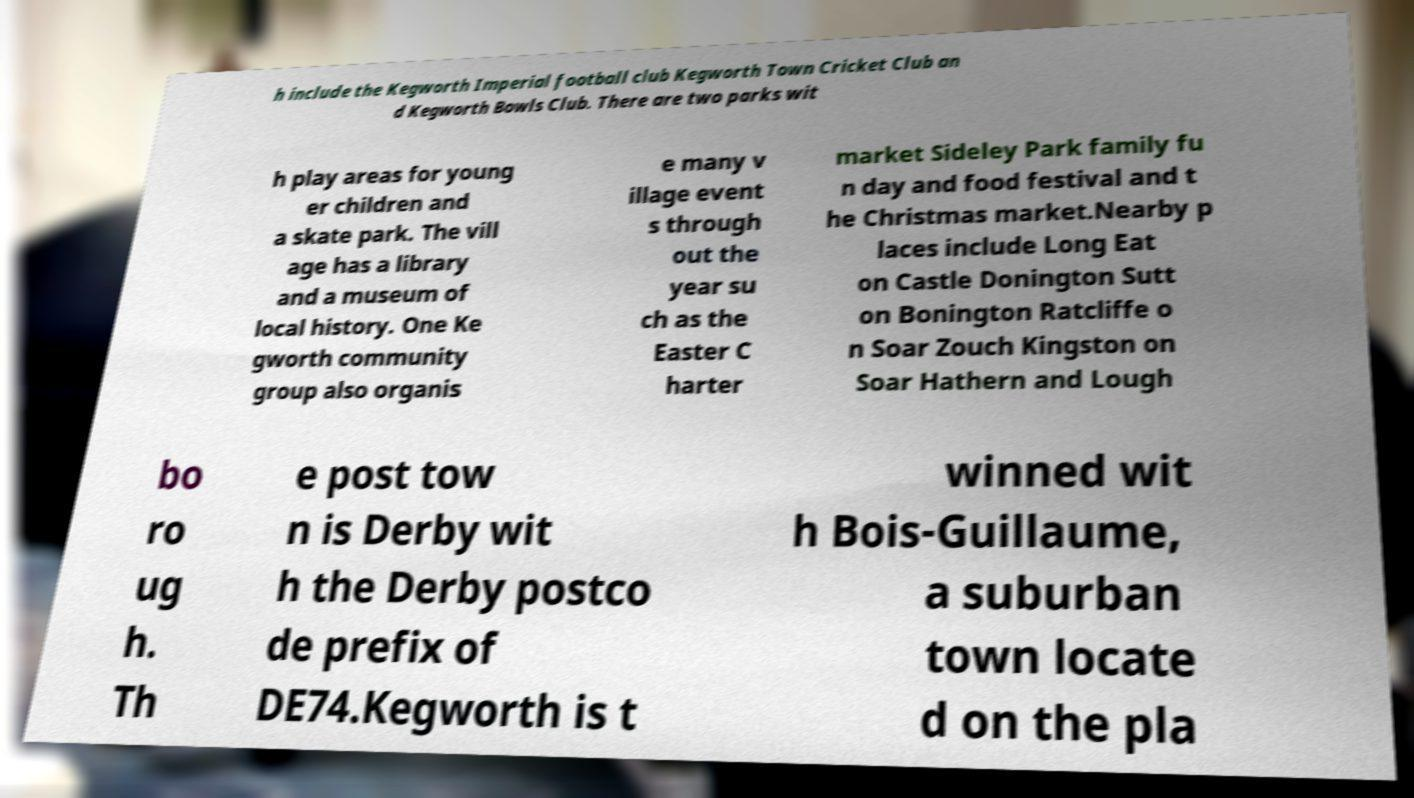Can you read and provide the text displayed in the image?This photo seems to have some interesting text. Can you extract and type it out for me? h include the Kegworth Imperial football club Kegworth Town Cricket Club an d Kegworth Bowls Club. There are two parks wit h play areas for young er children and a skate park. The vill age has a library and a museum of local history. One Ke gworth community group also organis e many v illage event s through out the year su ch as the Easter C harter market Sideley Park family fu n day and food festival and t he Christmas market.Nearby p laces include Long Eat on Castle Donington Sutt on Bonington Ratcliffe o n Soar Zouch Kingston on Soar Hathern and Lough bo ro ug h. Th e post tow n is Derby wit h the Derby postco de prefix of DE74.Kegworth is t winned wit h Bois-Guillaume, a suburban town locate d on the pla 